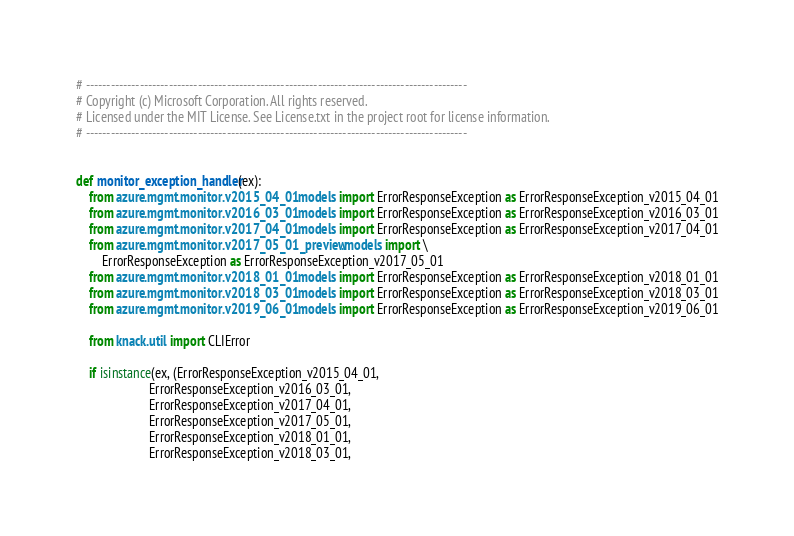<code> <loc_0><loc_0><loc_500><loc_500><_Python_># --------------------------------------------------------------------------------------------
# Copyright (c) Microsoft Corporation. All rights reserved.
# Licensed under the MIT License. See License.txt in the project root for license information.
# --------------------------------------------------------------------------------------------


def monitor_exception_handler(ex):
    from azure.mgmt.monitor.v2015_04_01.models import ErrorResponseException as ErrorResponseException_v2015_04_01
    from azure.mgmt.monitor.v2016_03_01.models import ErrorResponseException as ErrorResponseException_v2016_03_01
    from azure.mgmt.monitor.v2017_04_01.models import ErrorResponseException as ErrorResponseException_v2017_04_01
    from azure.mgmt.monitor.v2017_05_01_preview.models import \
        ErrorResponseException as ErrorResponseException_v2017_05_01
    from azure.mgmt.monitor.v2018_01_01.models import ErrorResponseException as ErrorResponseException_v2018_01_01
    from azure.mgmt.monitor.v2018_03_01.models import ErrorResponseException as ErrorResponseException_v2018_03_01
    from azure.mgmt.monitor.v2019_06_01.models import ErrorResponseException as ErrorResponseException_v2019_06_01

    from knack.util import CLIError

    if isinstance(ex, (ErrorResponseException_v2015_04_01,
                       ErrorResponseException_v2016_03_01,
                       ErrorResponseException_v2017_04_01,
                       ErrorResponseException_v2017_05_01,
                       ErrorResponseException_v2018_01_01,
                       ErrorResponseException_v2018_03_01,</code> 